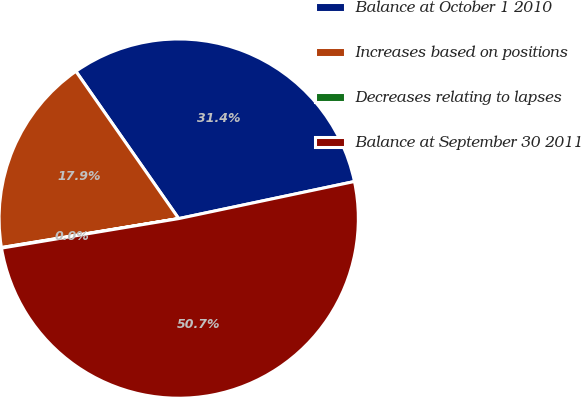<chart> <loc_0><loc_0><loc_500><loc_500><pie_chart><fcel>Balance at October 1 2010<fcel>Increases based on positions<fcel>Decreases relating to lapses<fcel>Balance at September 30 2011<nl><fcel>31.39%<fcel>17.88%<fcel>0.05%<fcel>50.69%<nl></chart> 